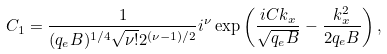<formula> <loc_0><loc_0><loc_500><loc_500>C _ { 1 } = \frac { 1 } { ( q _ { e } B ) ^ { 1 / 4 } \sqrt { \nu ! } 2 ^ { ( \nu - 1 ) / 2 } } i ^ { \nu } \exp \left ( \frac { i C k _ { x } } { \sqrt { q _ { e } B } } - \frac { k _ { x } ^ { 2 } } { 2 q _ { e } B } \right ) ,</formula> 